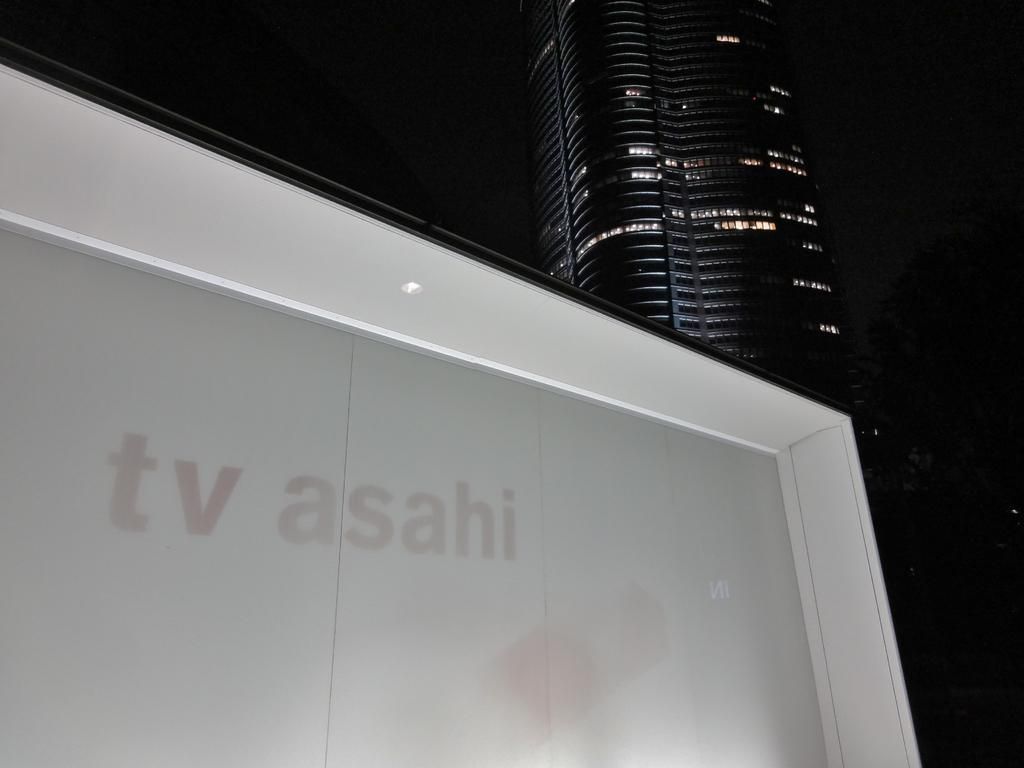What type of wall is shown in the image? There is a wall with glass in the image. What can be seen on the wall? A company name is represented on the wall. What is visible in the background of the image? There is a building and a tree in the background of the image. Are there any other objects visible in the background? Yes, there are other objects visible in the background. What time of day is it in the image, considering the presence of oranges? There are no oranges present in the image, so it is not possible to determine the time of day based on their presence. 